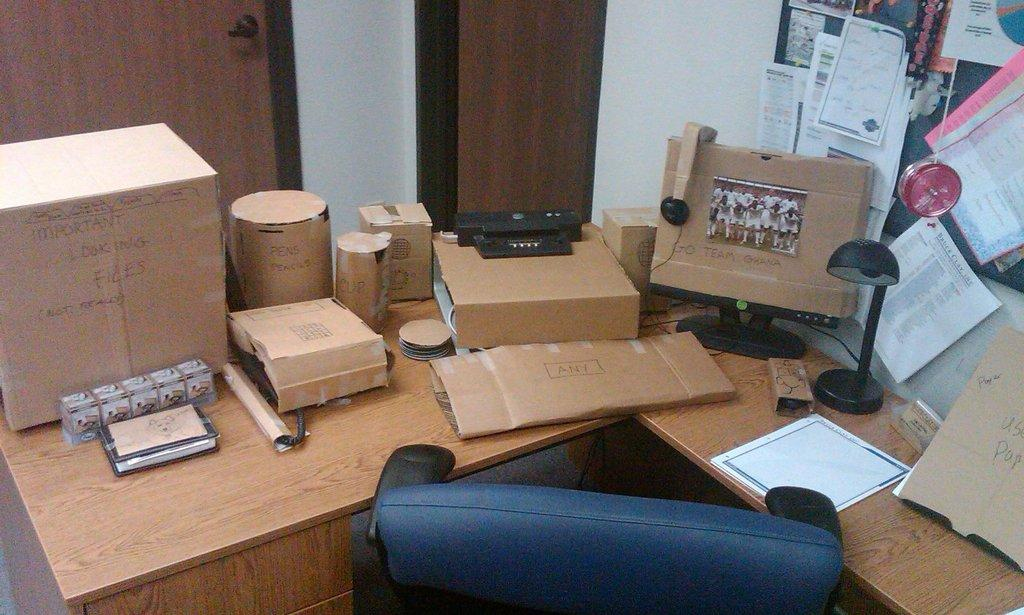What is the main piece of furniture in the image? There is a table in the image. What is placed on the table? There are many items on the table. What is located beside the table? There is a wall beside the table. What can be seen on the wall? There are notifications on a paper on the wall. What type of cheese is being discussed in the image? There is no cheese present in the image, nor is there any discussion about cheese. 